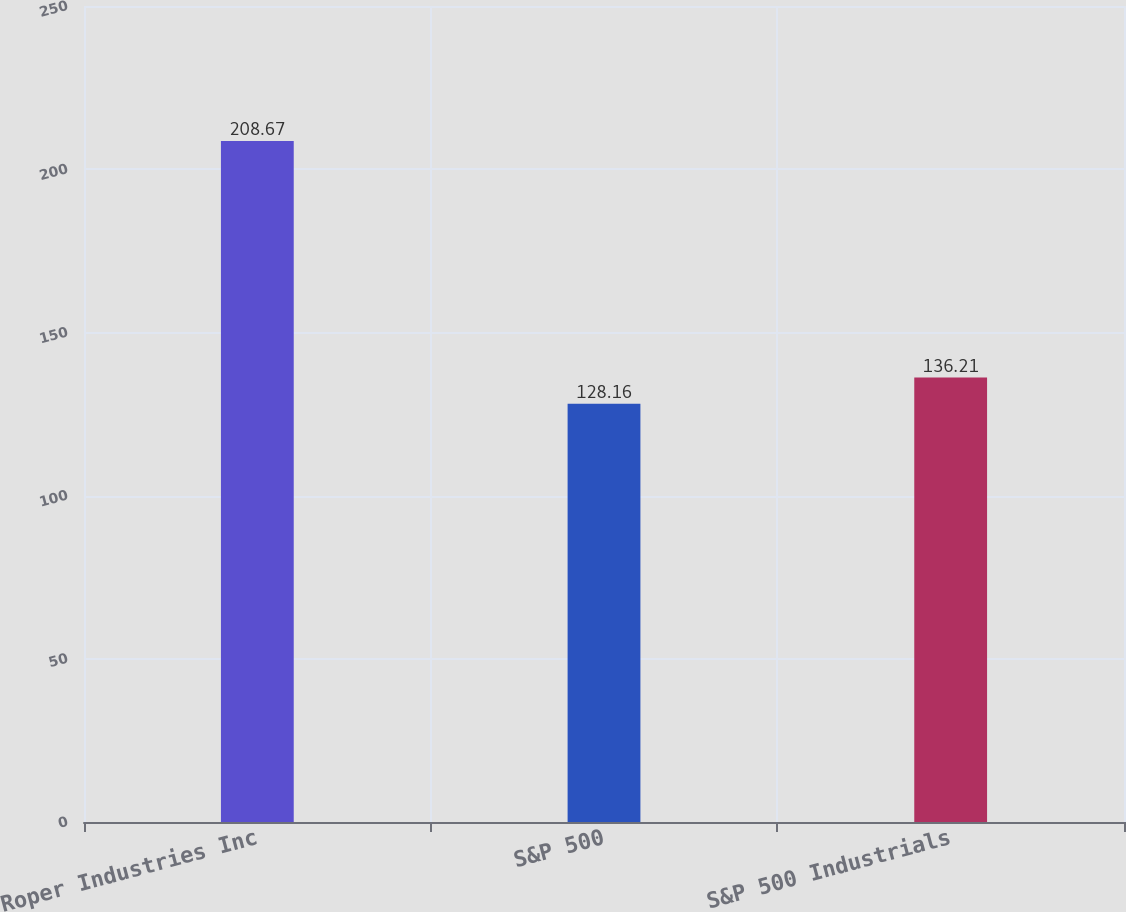<chart> <loc_0><loc_0><loc_500><loc_500><bar_chart><fcel>Roper Industries Inc<fcel>S&P 500<fcel>S&P 500 Industrials<nl><fcel>208.67<fcel>128.16<fcel>136.21<nl></chart> 